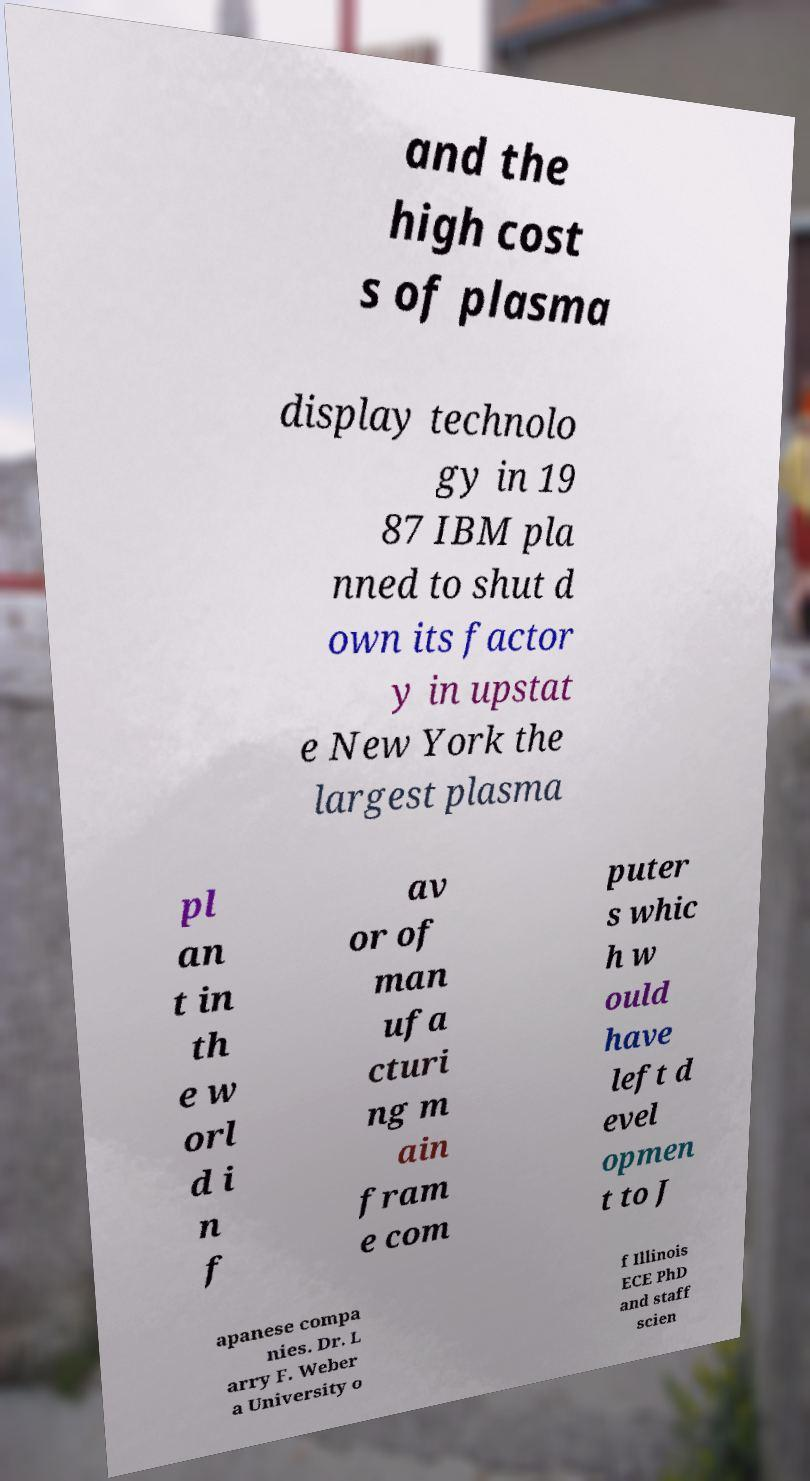For documentation purposes, I need the text within this image transcribed. Could you provide that? and the high cost s of plasma display technolo gy in 19 87 IBM pla nned to shut d own its factor y in upstat e New York the largest plasma pl an t in th e w orl d i n f av or of man ufa cturi ng m ain fram e com puter s whic h w ould have left d evel opmen t to J apanese compa nies. Dr. L arry F. Weber a University o f Illinois ECE PhD and staff scien 